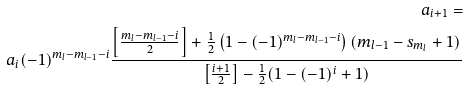Convert formula to latex. <formula><loc_0><loc_0><loc_500><loc_500>a _ { i + 1 } = \\ a _ { i } ( - 1 ) ^ { m _ { l } - m _ { l - 1 } - i } \frac { \left [ \frac { m _ { l } - m _ { l - 1 } - i } { 2 } \right ] + \frac { 1 } { 2 } \left ( 1 - ( - 1 ) ^ { m _ { l } - m _ { l - 1 } - i } \right ) ( m _ { l - 1 } - s _ { m _ { l } } + 1 ) } { \left [ \frac { i + 1 } { 2 } \right ] - \frac { 1 } { 2 } ( 1 - ( - 1 ) ^ { i } + 1 ) }</formula> 